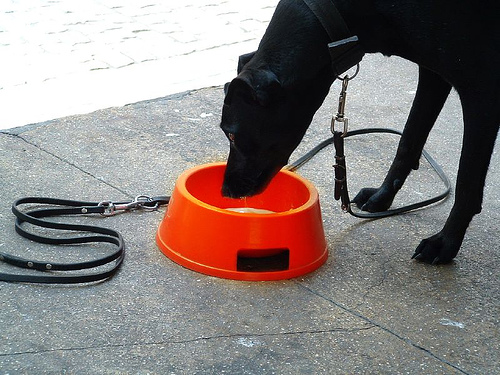<image>
Is the dog on the floor? Yes. Looking at the image, I can see the dog is positioned on top of the floor, with the floor providing support. Is the dog on the bowl? No. The dog is not positioned on the bowl. They may be near each other, but the dog is not supported by or resting on top of the bowl. 